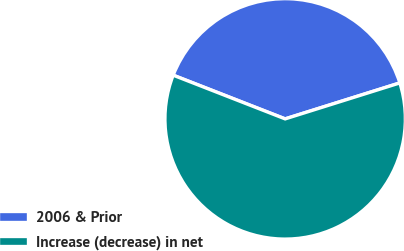Convert chart to OTSL. <chart><loc_0><loc_0><loc_500><loc_500><pie_chart><fcel>2006 & Prior<fcel>Increase (decrease) in net<nl><fcel>39.24%<fcel>60.76%<nl></chart> 